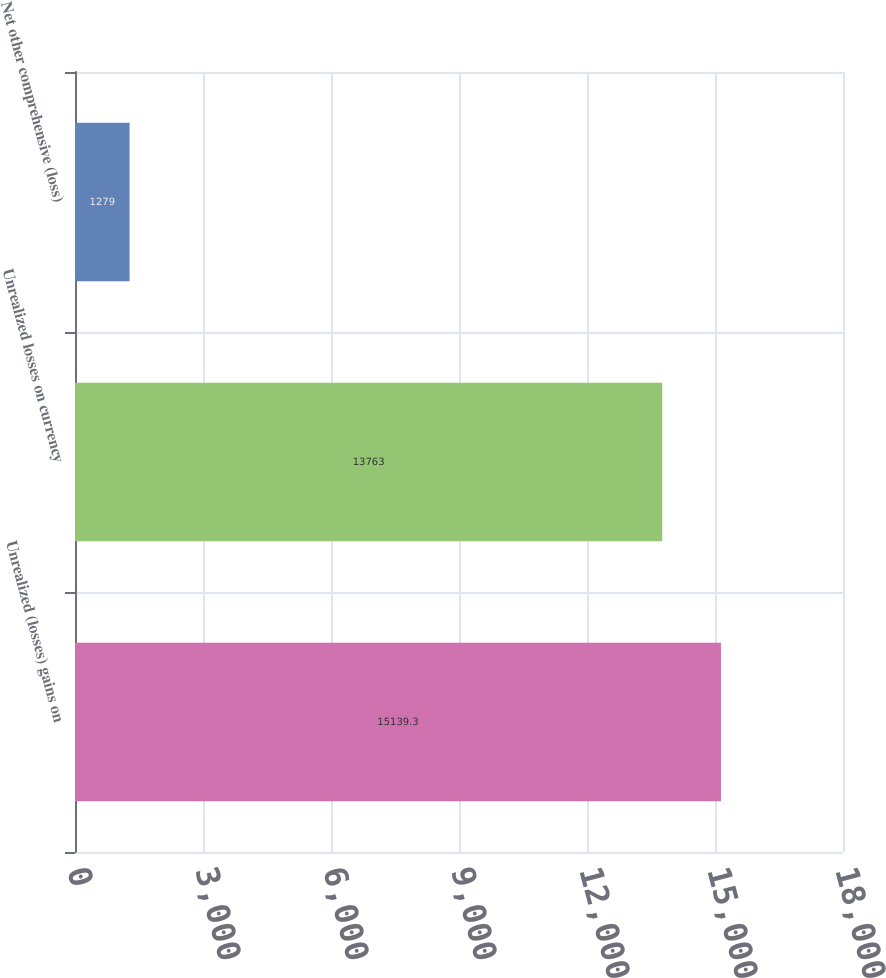Convert chart. <chart><loc_0><loc_0><loc_500><loc_500><bar_chart><fcel>Unrealized (losses) gains on<fcel>Unrealized losses on currency<fcel>Net other comprehensive (loss)<nl><fcel>15139.3<fcel>13763<fcel>1279<nl></chart> 